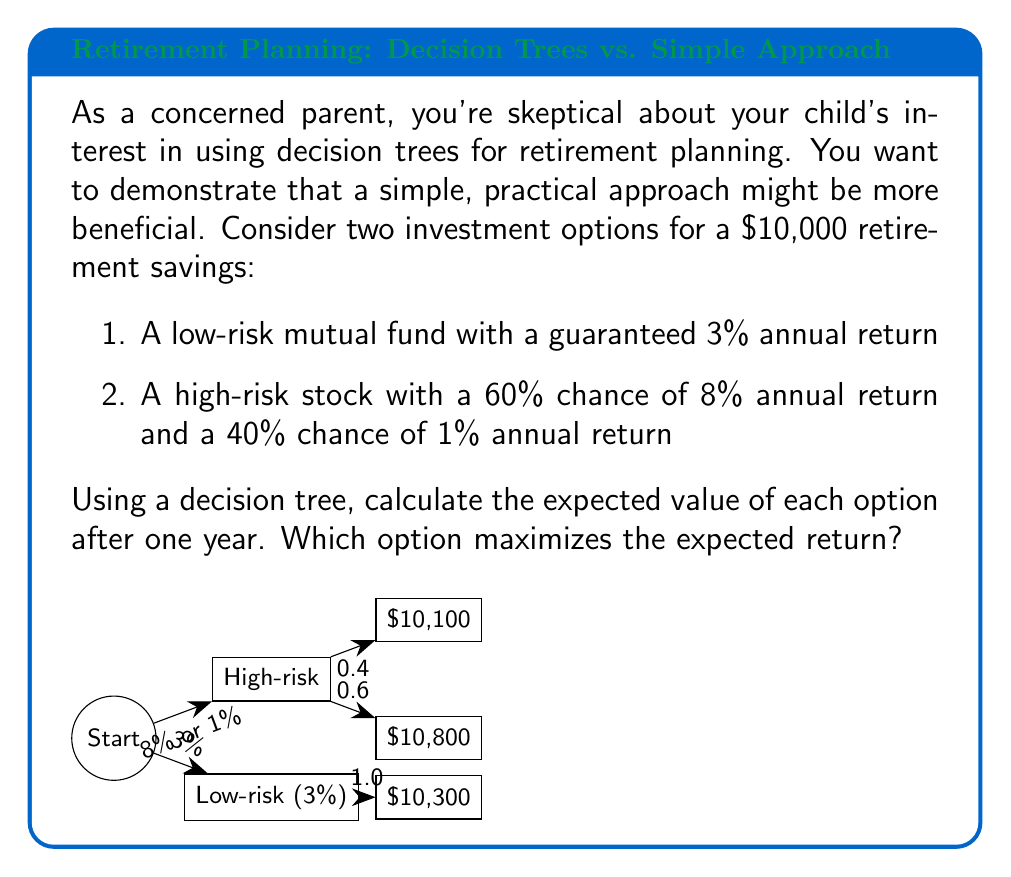Solve this math problem. Let's approach this step-by-step:

1) For the low-risk mutual fund:
   The return is guaranteed at 3%.
   $$\text{Expected Value} = \$10,000 \times (1 + 0.03) = \$10,300$$

2) For the high-risk stock:
   We need to calculate the weighted average of the two possible outcomes.
   
   a) 60% chance of 8% return:
      $$0.60 \times \$10,000 \times (1 + 0.08) = \$6,480$$
   
   b) 40% chance of 1% return:
      $$0.40 \times \$10,000 \times (1 + 0.01) = \$4,040$$
   
   c) Expected Value:
      $$\text{Expected Value} = \$6,480 + \$4,040 = \$10,520$$

3) Comparing the two options:
   Low-risk mutual fund: $10,300
   High-risk stock: $10,520

The high-risk stock has a higher expected value after one year.
Answer: High-risk stock option, with an expected value of $10,520 